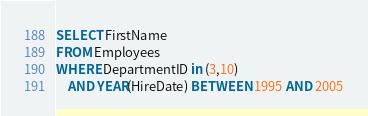<code> <loc_0><loc_0><loc_500><loc_500><_SQL_>SELECT FirstName
FROM Employees
WHERE DepartmentID in (3,10)
    AND YEAR(HireDate) BETWEEN 1995 AND 2005
</code> 